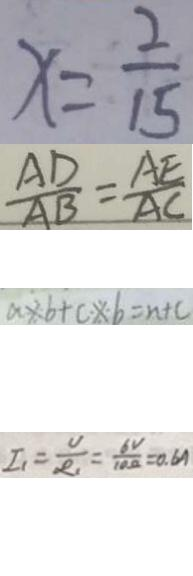Convert formula to latex. <formula><loc_0><loc_0><loc_500><loc_500>x = \frac { 2 } { 1 5 } 
 \frac { A D } { A B } = \frac { A E } { A C } 
 a \times b + c \times - b = n + c 
 I _ { 1 } = \frac { U } { R _ { 1 } } = \frac { 6 V } { 1 0 \Omega } = 0 . 6 A</formula> 